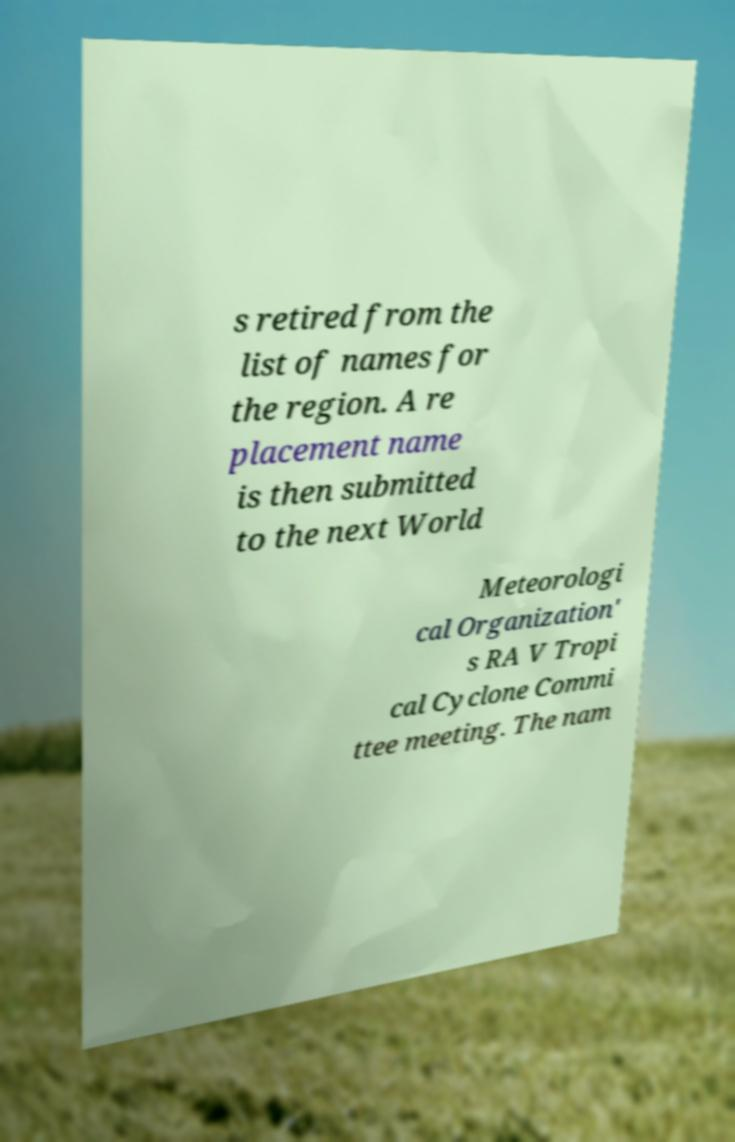Can you accurately transcribe the text from the provided image for me? s retired from the list of names for the region. A re placement name is then submitted to the next World Meteorologi cal Organization' s RA V Tropi cal Cyclone Commi ttee meeting. The nam 